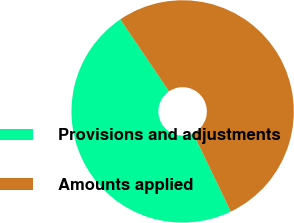Convert chart to OTSL. <chart><loc_0><loc_0><loc_500><loc_500><pie_chart><fcel>Provisions and adjustments<fcel>Amounts applied<nl><fcel>47.67%<fcel>52.33%<nl></chart> 